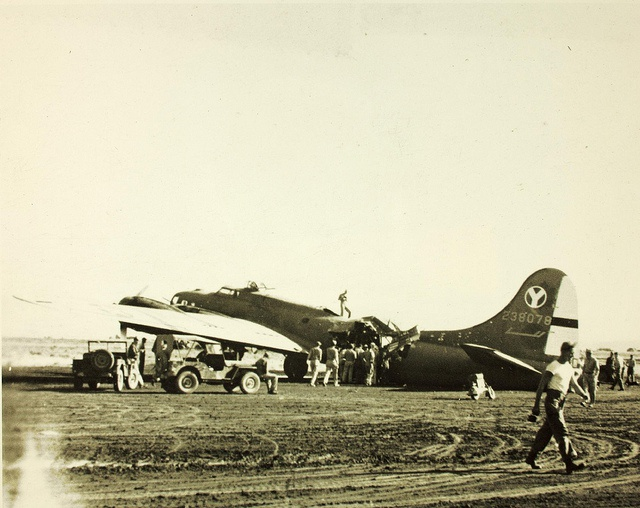Describe the objects in this image and their specific colors. I can see airplane in beige, black, darkgreen, and olive tones, truck in beige, black, and tan tones, people in beige, black, tan, and darkgreen tones, truck in beige, black, and darkgreen tones, and people in beige, black, darkgreen, gray, and olive tones in this image. 